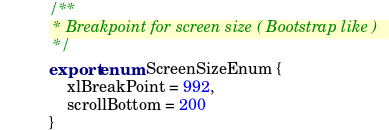<code> <loc_0><loc_0><loc_500><loc_500><_TypeScript_>/**
 * Breakpoint for screen size ( Bootstrap like )
 */
export enum ScreenSizeEnum {
    xlBreakPoint = 992,
    scrollBottom = 200
}</code> 